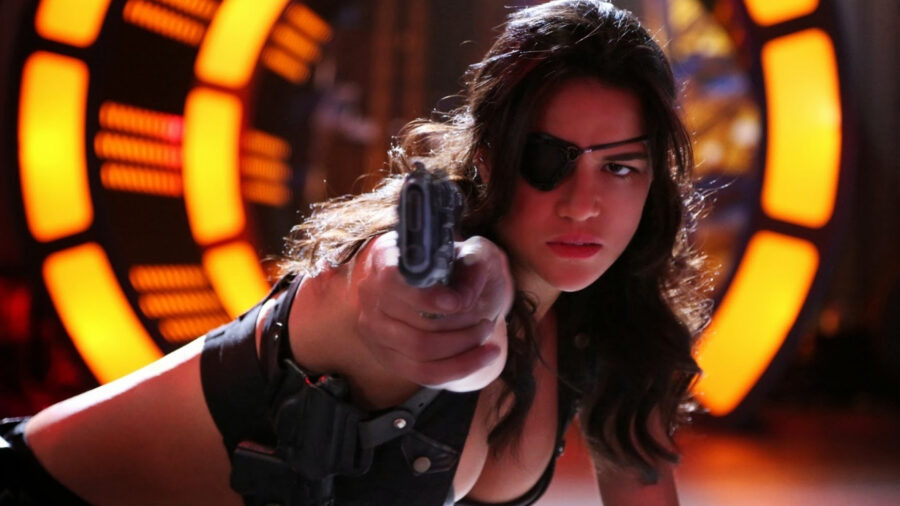What is this photo about? In the image, a woman is captured in a moment of intense action. She is centrally positioned, her face set in a serious expression as she points a gun directly toward the camera. Clad in a black tank top, sunglasses, and an eyepatch, she embodies a tough, no-nonsense persona. The background is ablaze with a futuristic display of lights in vibrant shades of orange and yellow, adding to the overall intensity of the scene. The dynamic elements suggest a thrilling, possibly futuristic action scenario. 